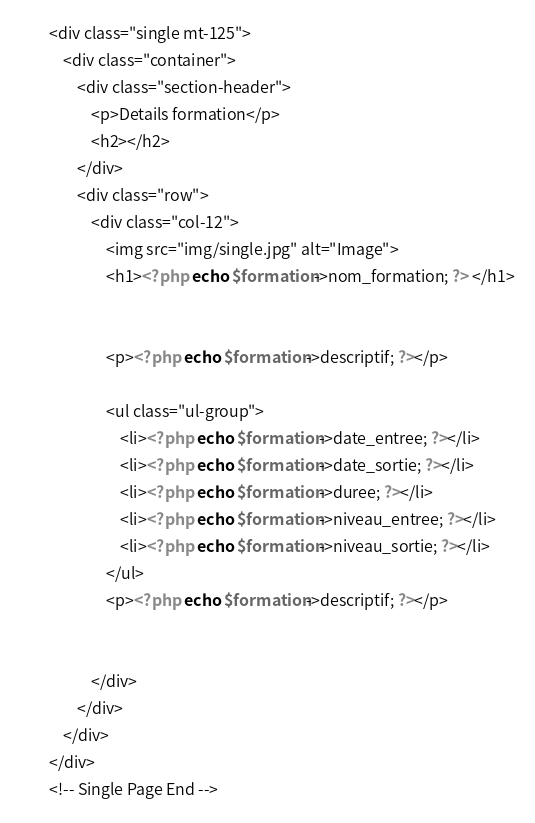<code> <loc_0><loc_0><loc_500><loc_500><_PHP_>        <div class="single mt-125">
            <div class="container">
                <div class="section-header">
                    <p>Details formation</p>
                    <h2></h2>
                </div>
                <div class="row">
                    <div class="col-12">
                        <img src="img/single.jpg" alt="Image">
                        <h1><?php echo $formation->nom_formation; ?> </h1>
                        
                                                    
                        <p><?php echo $formation->descriptif; ?></p>

                        <ul class="ul-group">
                            <li><?php echo $formation->date_entree; ?></li>
                            <li><?php echo $formation->date_sortie; ?></li>
                            <li><?php echo $formation->duree; ?></li>
                            <li><?php echo $formation->niveau_entree; ?></li>
                            <li><?php echo $formation->niveau_sortie; ?></li>
                        </ul>
                        <p><?php echo $formation->descriptif; ?></p>
                            
                       
                    </div>
                </div>
            </div>
        </div>
        <!-- Single Page End --></code> 